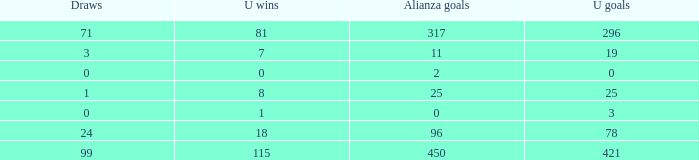What is the sum of Alianza Wins, when Alianza Goals is "317, and when U Goals is greater than 296? None. Help me parse the entirety of this table. {'header': ['Draws', 'U wins', 'Alianza goals', 'U goals'], 'rows': [['71', '81', '317', '296'], ['3', '7', '11', '19'], ['0', '0', '2', '0'], ['1', '8', '25', '25'], ['0', '1', '0', '3'], ['24', '18', '96', '78'], ['99', '115', '450', '421']]} 